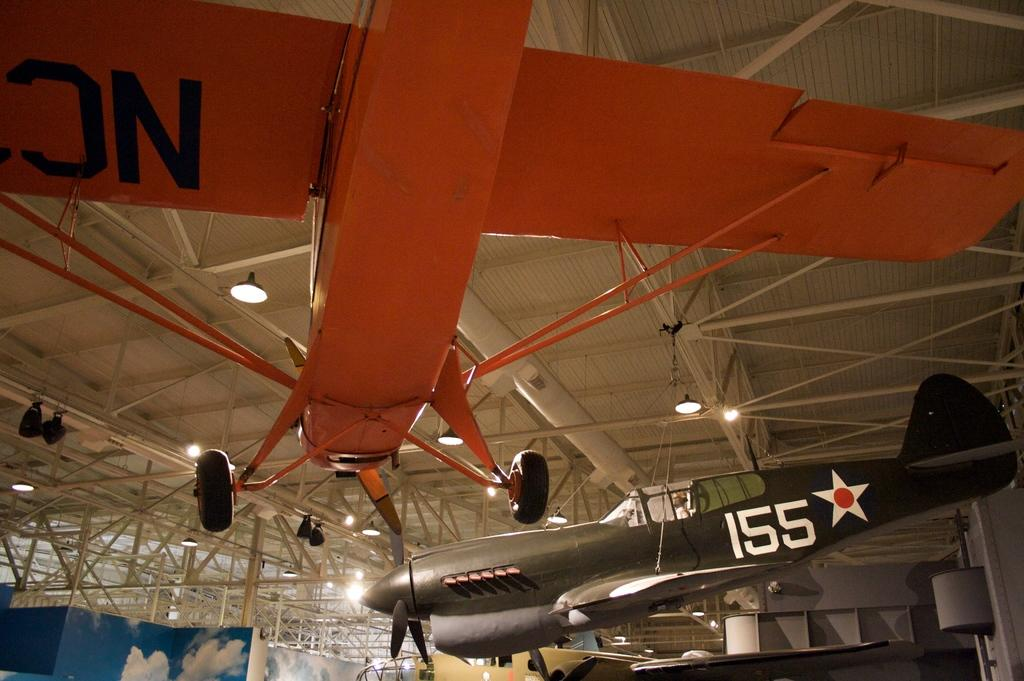<image>
Render a clear and concise summary of the photo. A few airplanes are on display inside of a building, one has 155 on it. 